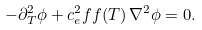<formula> <loc_0><loc_0><loc_500><loc_500>- \partial _ { T } ^ { 2 } \phi + c ^ { 2 } _ { e } f f ( T ) \, \nabla ^ { 2 } \phi = 0 .</formula> 